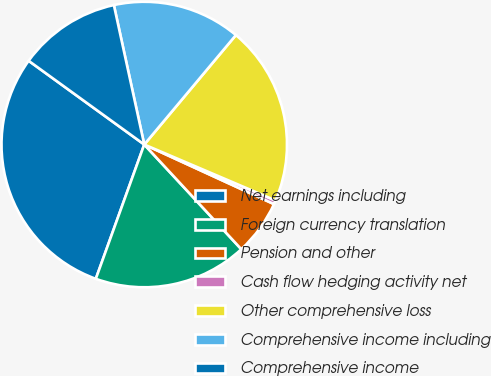Convert chart. <chart><loc_0><loc_0><loc_500><loc_500><pie_chart><fcel>Net earnings including<fcel>Foreign currency translation<fcel>Pension and other<fcel>Cash flow hedging activity net<fcel>Other comprehensive loss<fcel>Comprehensive income including<fcel>Comprehensive income<nl><fcel>29.47%<fcel>17.41%<fcel>6.25%<fcel>0.44%<fcel>20.32%<fcel>14.51%<fcel>11.61%<nl></chart> 